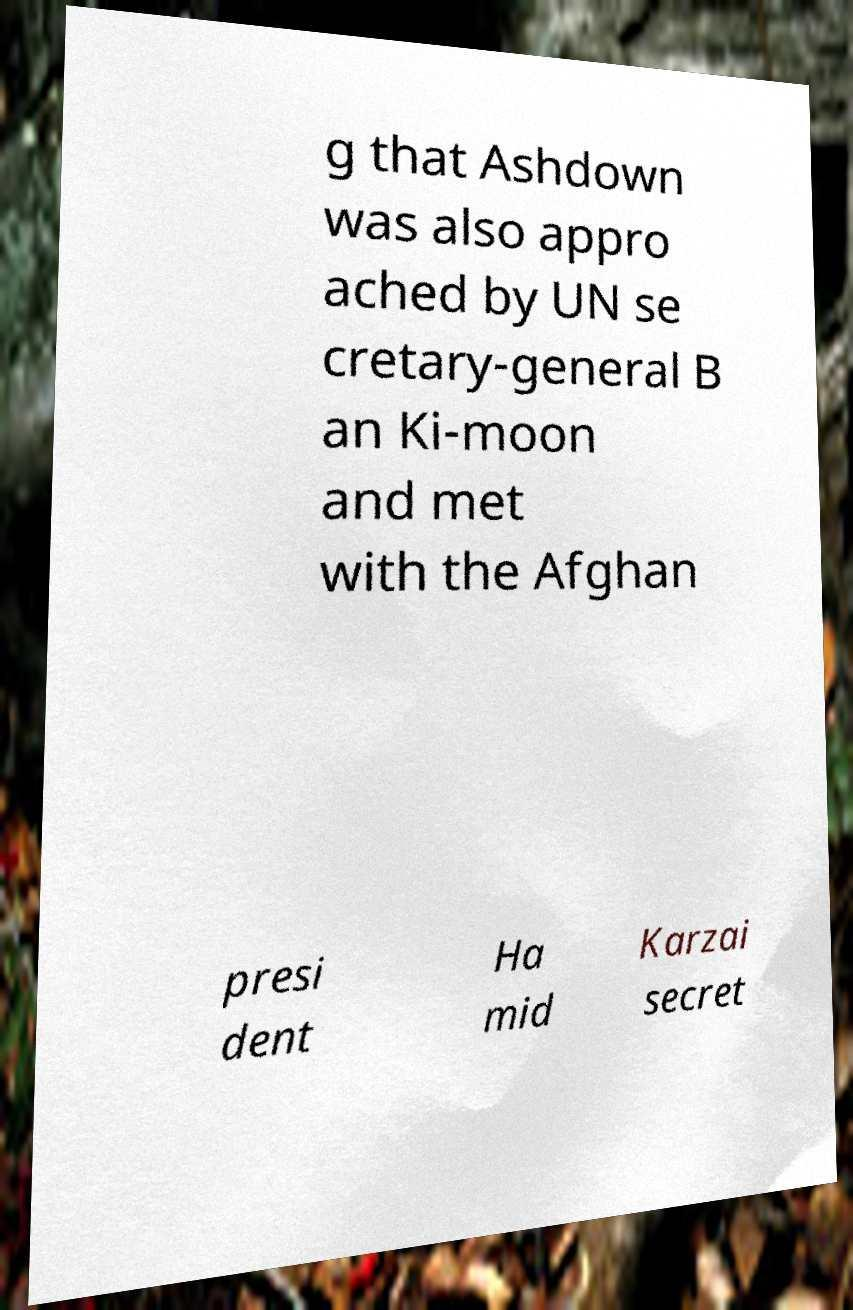I need the written content from this picture converted into text. Can you do that? g that Ashdown was also appro ached by UN se cretary-general B an Ki-moon and met with the Afghan presi dent Ha mid Karzai secret 